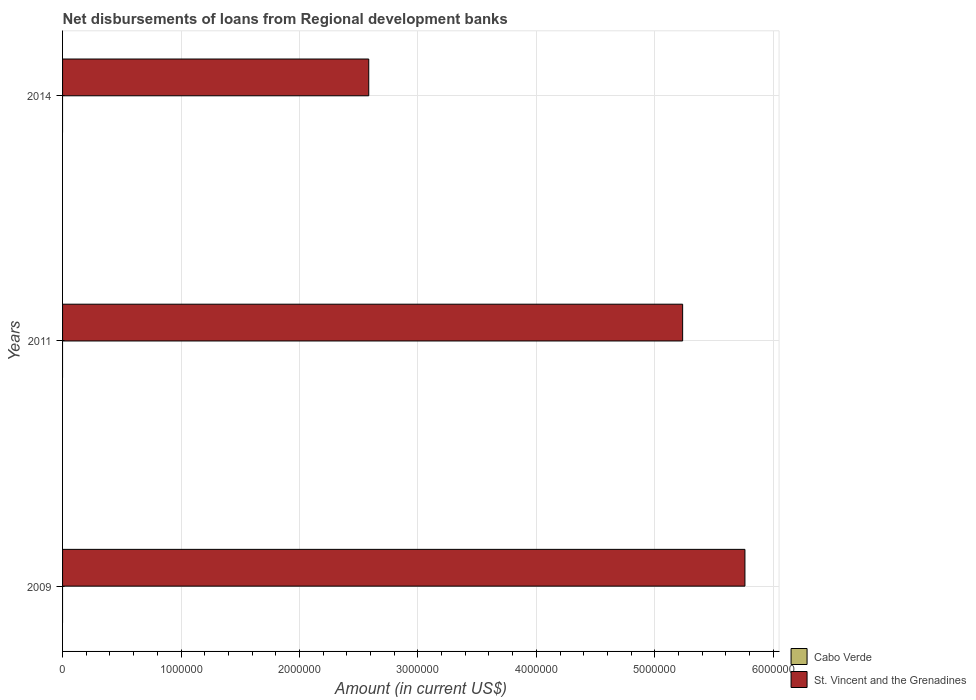How many different coloured bars are there?
Give a very brief answer. 1. Are the number of bars on each tick of the Y-axis equal?
Offer a terse response. Yes. What is the label of the 2nd group of bars from the top?
Offer a terse response. 2011. What is the amount of disbursements of loans from regional development banks in St. Vincent and the Grenadines in 2009?
Your answer should be compact. 5.76e+06. Across all years, what is the maximum amount of disbursements of loans from regional development banks in St. Vincent and the Grenadines?
Offer a terse response. 5.76e+06. Across all years, what is the minimum amount of disbursements of loans from regional development banks in St. Vincent and the Grenadines?
Offer a very short reply. 2.58e+06. In which year was the amount of disbursements of loans from regional development banks in St. Vincent and the Grenadines maximum?
Give a very brief answer. 2009. What is the difference between the amount of disbursements of loans from regional development banks in St. Vincent and the Grenadines in 2011 and that in 2014?
Keep it short and to the point. 2.65e+06. What is the difference between the amount of disbursements of loans from regional development banks in Cabo Verde in 2009 and the amount of disbursements of loans from regional development banks in St. Vincent and the Grenadines in 2014?
Keep it short and to the point. -2.58e+06. What is the average amount of disbursements of loans from regional development banks in St. Vincent and the Grenadines per year?
Give a very brief answer. 4.53e+06. What is the ratio of the amount of disbursements of loans from regional development banks in St. Vincent and the Grenadines in 2009 to that in 2014?
Make the answer very short. 2.23. Is the amount of disbursements of loans from regional development banks in St. Vincent and the Grenadines in 2011 less than that in 2014?
Provide a short and direct response. No. What is the difference between the highest and the second highest amount of disbursements of loans from regional development banks in St. Vincent and the Grenadines?
Provide a succinct answer. 5.26e+05. In how many years, is the amount of disbursements of loans from regional development banks in St. Vincent and the Grenadines greater than the average amount of disbursements of loans from regional development banks in St. Vincent and the Grenadines taken over all years?
Your response must be concise. 2. Is the sum of the amount of disbursements of loans from regional development banks in St. Vincent and the Grenadines in 2009 and 2014 greater than the maximum amount of disbursements of loans from regional development banks in Cabo Verde across all years?
Your answer should be very brief. Yes. Are all the bars in the graph horizontal?
Your answer should be compact. Yes. What is the difference between two consecutive major ticks on the X-axis?
Your answer should be compact. 1.00e+06. Are the values on the major ticks of X-axis written in scientific E-notation?
Provide a short and direct response. No. Does the graph contain any zero values?
Your answer should be very brief. Yes. Does the graph contain grids?
Provide a short and direct response. Yes. What is the title of the graph?
Your answer should be compact. Net disbursements of loans from Regional development banks. What is the label or title of the X-axis?
Your answer should be compact. Amount (in current US$). What is the Amount (in current US$) in Cabo Verde in 2009?
Provide a succinct answer. 0. What is the Amount (in current US$) of St. Vincent and the Grenadines in 2009?
Ensure brevity in your answer.  5.76e+06. What is the Amount (in current US$) in St. Vincent and the Grenadines in 2011?
Ensure brevity in your answer.  5.24e+06. What is the Amount (in current US$) of Cabo Verde in 2014?
Make the answer very short. 0. What is the Amount (in current US$) in St. Vincent and the Grenadines in 2014?
Give a very brief answer. 2.58e+06. Across all years, what is the maximum Amount (in current US$) in St. Vincent and the Grenadines?
Your answer should be compact. 5.76e+06. Across all years, what is the minimum Amount (in current US$) in St. Vincent and the Grenadines?
Give a very brief answer. 2.58e+06. What is the total Amount (in current US$) of St. Vincent and the Grenadines in the graph?
Offer a terse response. 1.36e+07. What is the difference between the Amount (in current US$) in St. Vincent and the Grenadines in 2009 and that in 2011?
Offer a terse response. 5.26e+05. What is the difference between the Amount (in current US$) in St. Vincent and the Grenadines in 2009 and that in 2014?
Give a very brief answer. 3.18e+06. What is the difference between the Amount (in current US$) of St. Vincent and the Grenadines in 2011 and that in 2014?
Your response must be concise. 2.65e+06. What is the average Amount (in current US$) in Cabo Verde per year?
Your answer should be very brief. 0. What is the average Amount (in current US$) in St. Vincent and the Grenadines per year?
Ensure brevity in your answer.  4.53e+06. What is the ratio of the Amount (in current US$) of St. Vincent and the Grenadines in 2009 to that in 2011?
Make the answer very short. 1.1. What is the ratio of the Amount (in current US$) of St. Vincent and the Grenadines in 2009 to that in 2014?
Provide a short and direct response. 2.23. What is the ratio of the Amount (in current US$) of St. Vincent and the Grenadines in 2011 to that in 2014?
Provide a short and direct response. 2.03. What is the difference between the highest and the second highest Amount (in current US$) in St. Vincent and the Grenadines?
Ensure brevity in your answer.  5.26e+05. What is the difference between the highest and the lowest Amount (in current US$) of St. Vincent and the Grenadines?
Provide a short and direct response. 3.18e+06. 